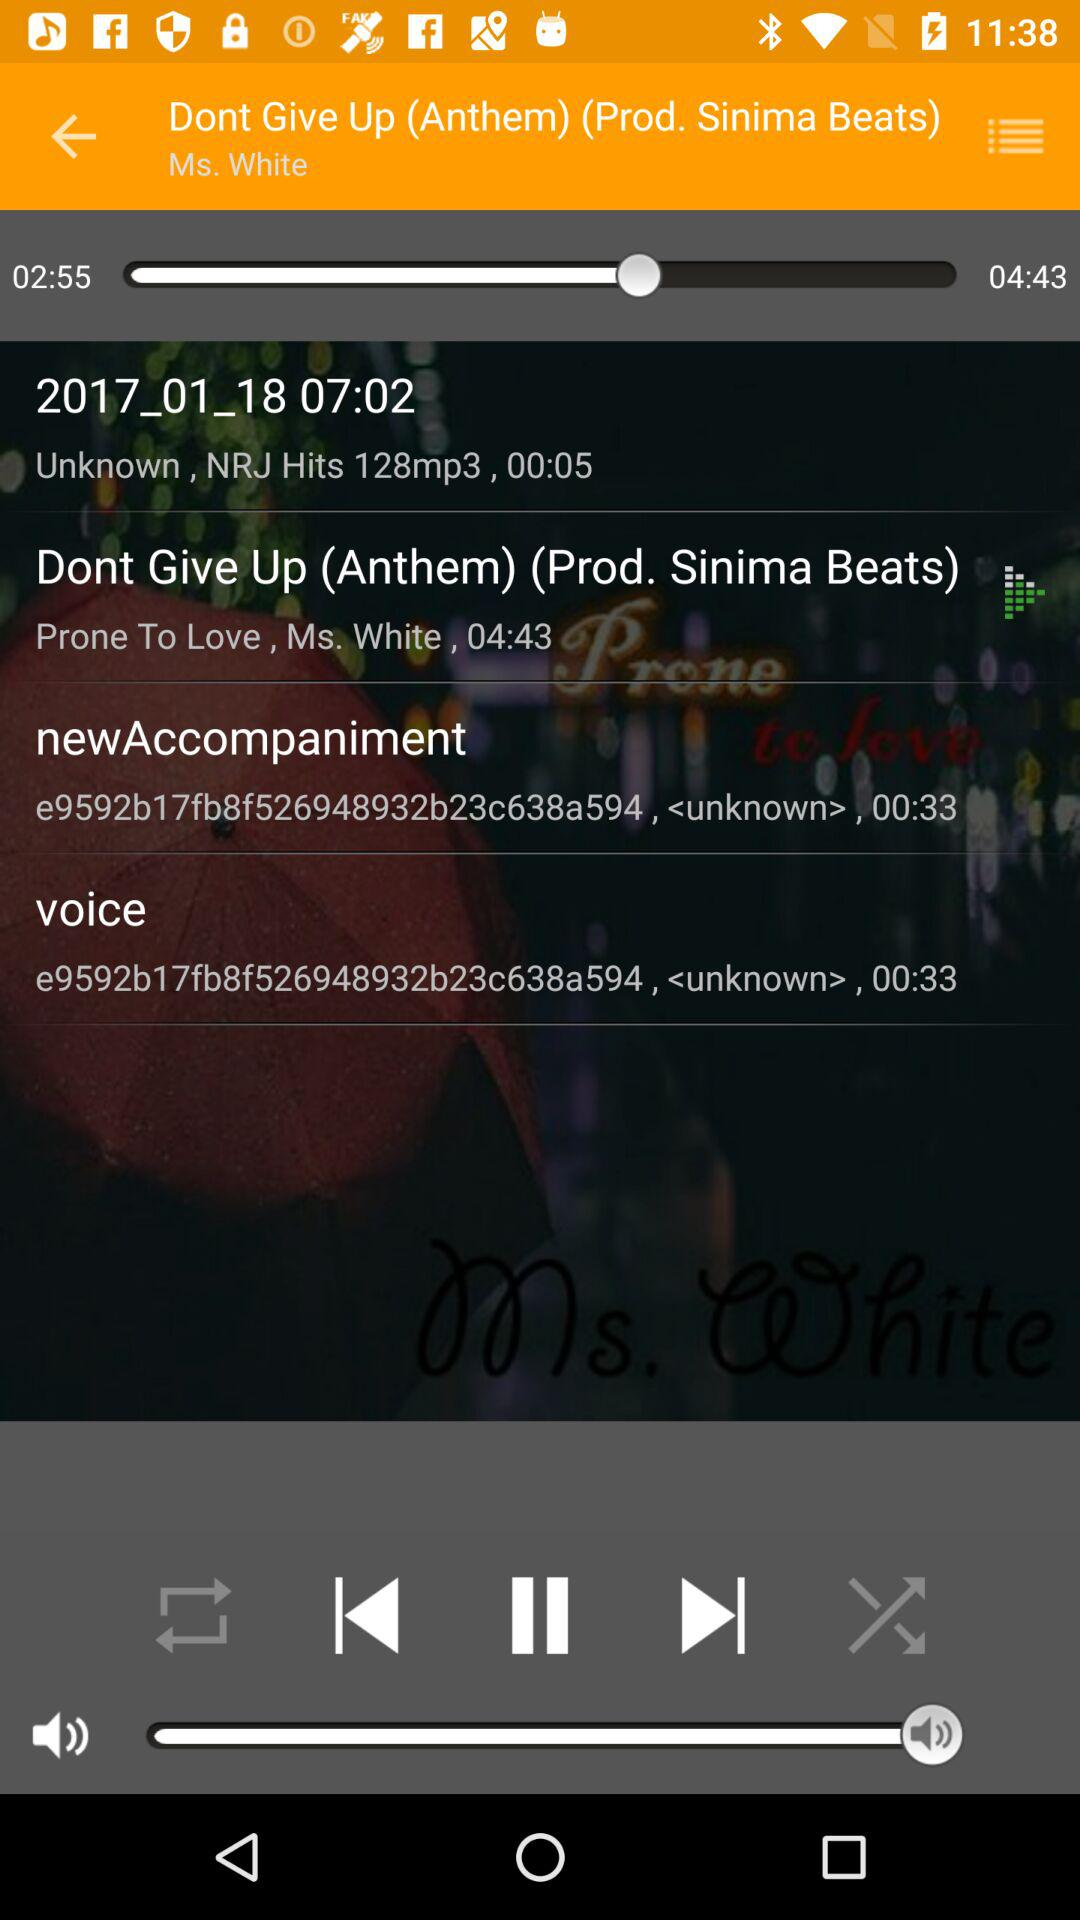What is the description of the "voice"? The description of the "voice" is "e9592b17fb8f526948932b23c638a594, <unknown>, 00:33". 